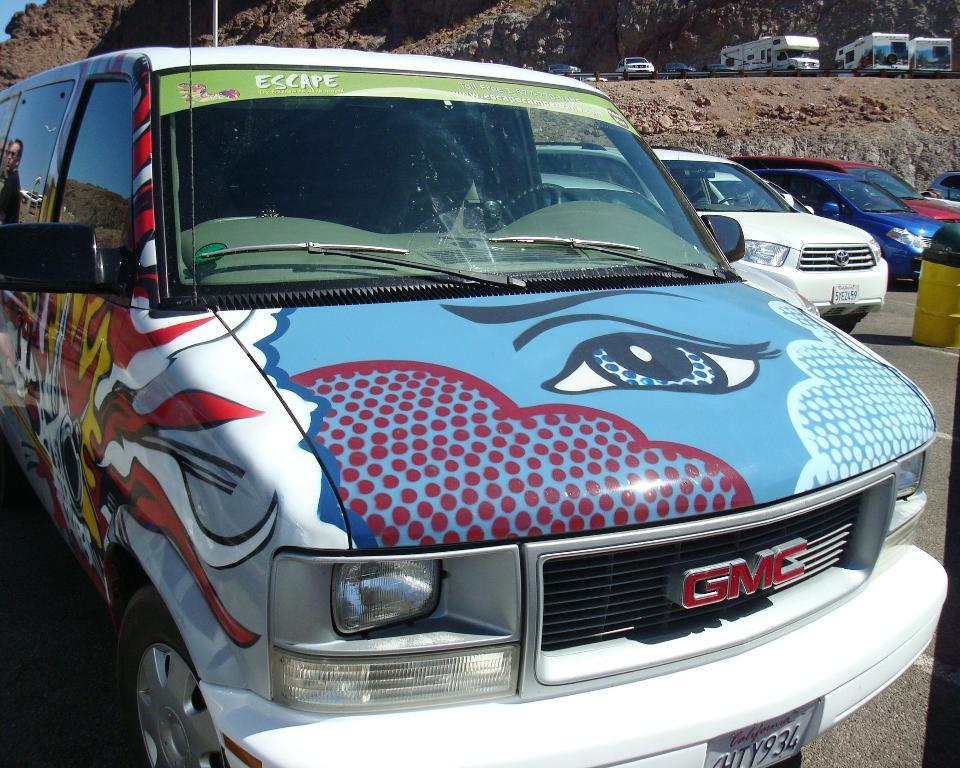<image>
Give a short and clear explanation of the subsequent image. A vividly painted GMC van has a bright blue eye on its hood. 